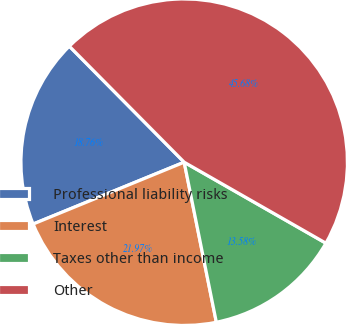<chart> <loc_0><loc_0><loc_500><loc_500><pie_chart><fcel>Professional liability risks<fcel>Interest<fcel>Taxes other than income<fcel>Other<nl><fcel>18.76%<fcel>21.97%<fcel>13.58%<fcel>45.68%<nl></chart> 